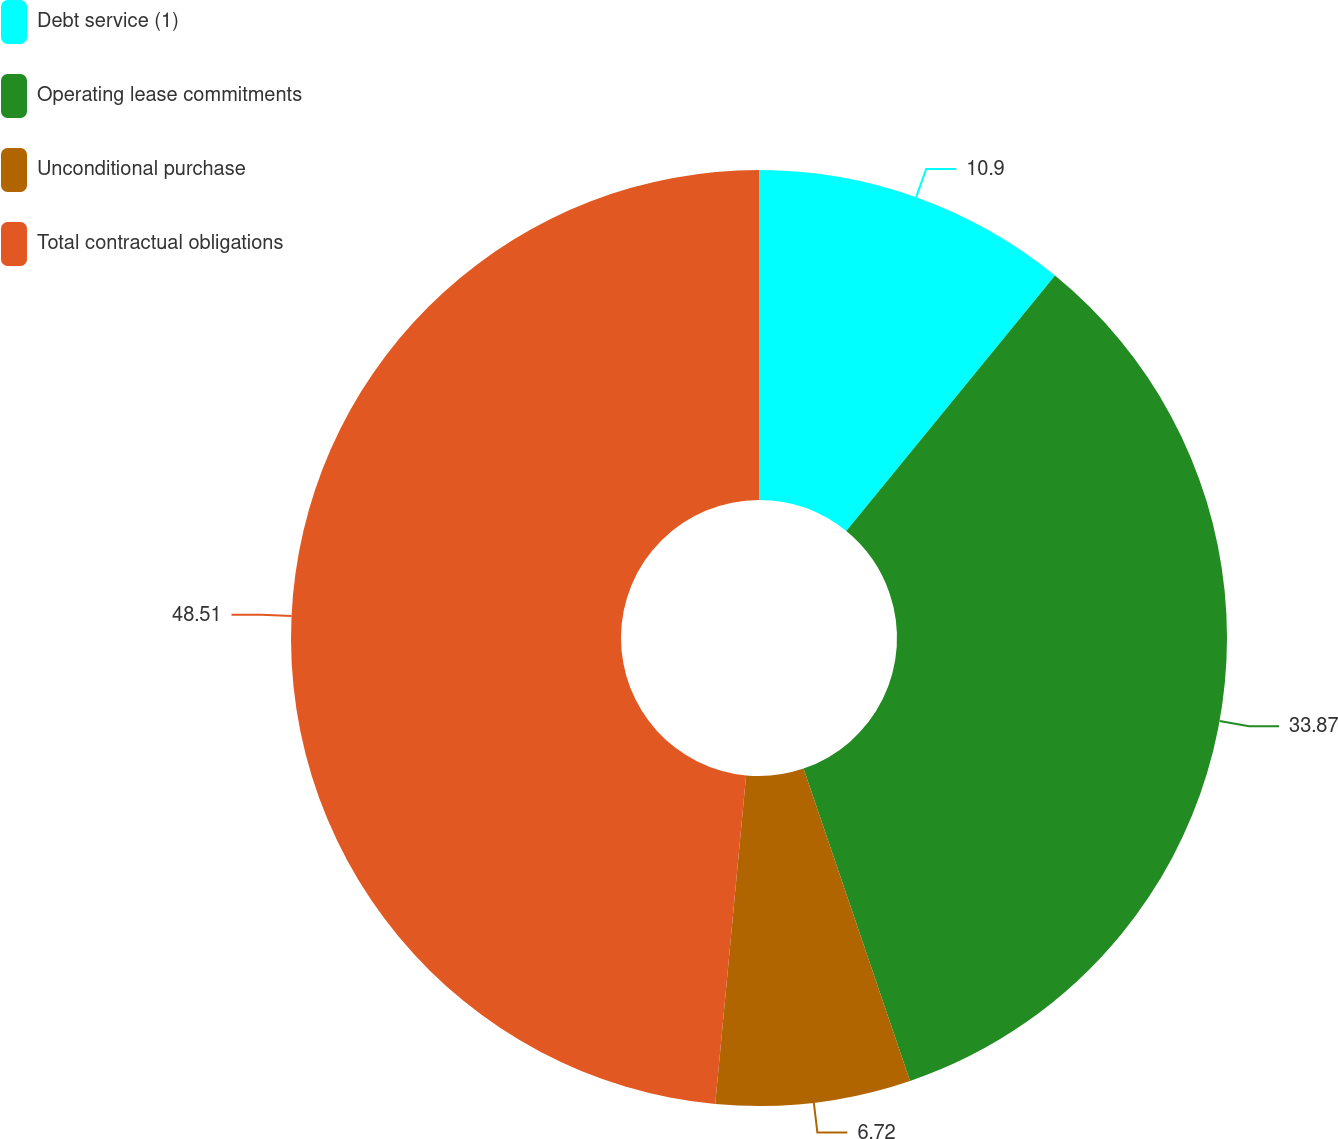<chart> <loc_0><loc_0><loc_500><loc_500><pie_chart><fcel>Debt service (1)<fcel>Operating lease commitments<fcel>Unconditional purchase<fcel>Total contractual obligations<nl><fcel>10.9%<fcel>33.87%<fcel>6.72%<fcel>48.51%<nl></chart> 